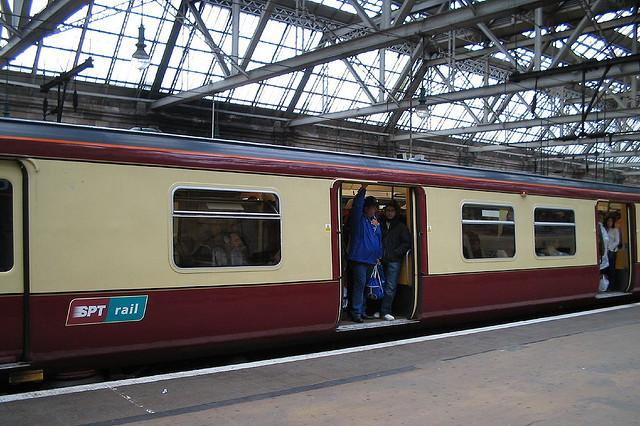What is the person wearing the blue coat about to do? exit train 